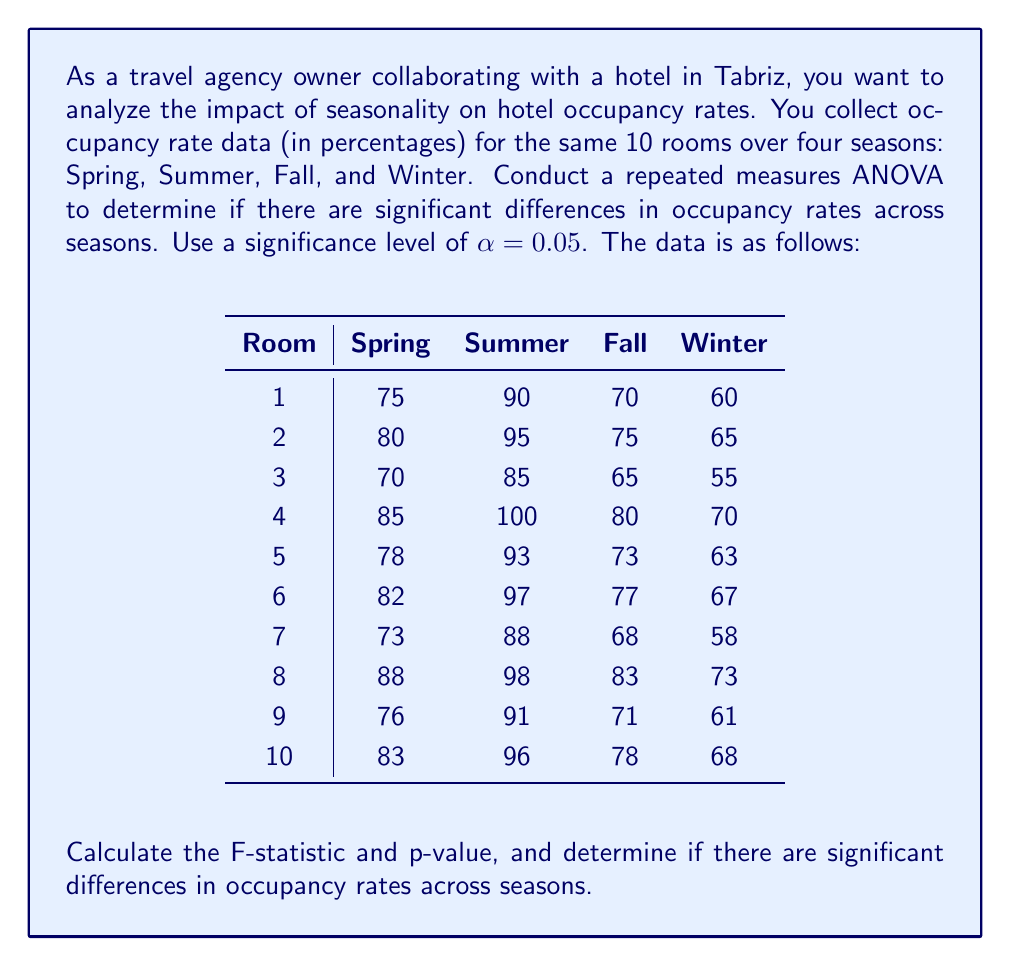Can you answer this question? To conduct a repeated measures ANOVA, we'll follow these steps:

1. Calculate the mean for each season:
   Spring: $\bar{X}_S = 79$
   Summer: $\bar{X}_U = 93.3$
   Fall: $\bar{X}_F = 74$
   Winter: $\bar{X}_W = 64$

2. Calculate the grand mean:
   $\bar{X}_G = (79 + 93.3 + 74 + 64) / 4 = 77.575$

3. Calculate SST (Total Sum of Squares):
   $$SST = \sum_{i=1}^{4}\sum_{j=1}^{10} (X_{ij} - \bar{X}_G)^2 = 13,764.675$$

4. Calculate SSB (Between-Treatments Sum of Squares):
   $$SSB = 10 \times [(79 - 77.575)^2 + (93.3 - 77.575)^2 + (74 - 77.575)^2 + (64 - 77.575)^2] = 4,588.225$$

5. Calculate SSW (Within-Treatments Sum of Squares):
   $$SSW = SST - SSB = 13,764.675 - 4,588.225 = 9,176.45$$

6. Calculate SSSubjects (Sum of Squares for Subjects):
   $$SSSubjects = 4 \times \sum_{i=1}^{10} (\bar{X}_i - \bar{X}_G)^2 = 1,533.5$$

7. Calculate SSError (Error Sum of Squares):
   $$SSError = SSW - SSSubjects = 9,176.45 - 1,533.5 = 7,642.95$$

8. Calculate degrees of freedom:
   $df_{treatments} = 4 - 1 = 3$
   $df_{subjects} = 10 - 1 = 9$
   $df_{error} = (4 - 1) \times (10 - 1) = 27$

9. Calculate Mean Squares:
   $$MS_{treatments} = SSB / df_{treatments} = 4,588.225 / 3 = 1,529.408$$
   $$MS_{error} = SSError / df_{error} = 7,642.95 / 27 = 283.072$$

10. Calculate F-statistic:
    $$F = MS_{treatments} / MS_{error} = 1,529.408 / 283.072 = 5.403$$

11. Find the critical F-value:
    With $df_{treatments} = 3$ and $df_{error} = 27$, and $\alpha = 0.05$, the critical F-value is approximately 2.96.

12. Calculate p-value:
    Using an F-distribution calculator with $F = 5.403$, $df_1 = 3$, and $df_2 = 27$, we get $p \approx 0.0048$.

Since $F = 5.403 > F_{critical} = 2.96$ and $p = 0.0048 < \alpha = 0.05$, we reject the null hypothesis.
Answer: F-statistic: 5.403
p-value: 0.0048
Conclusion: There are significant differences in occupancy rates across seasons in Tabriz (F(3, 27) = 5.403, p = 0.0048 < 0.05). 